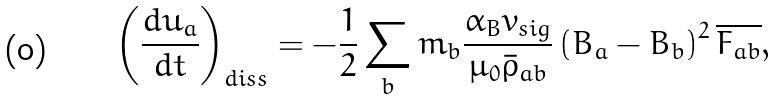<formula> <loc_0><loc_0><loc_500><loc_500>\left ( \frac { d u _ { a } } { d t } \right ) _ { d i s s } = - \frac { 1 } { 2 } \sum _ { b } m _ { b } \frac { \alpha _ { B } v _ { s i g } } { \mu _ { 0 } \bar { \rho } _ { a b } } \left ( { B } _ { a } - { B } _ { b } \right ) ^ { 2 } \overline { F _ { a b } } ,</formula> 